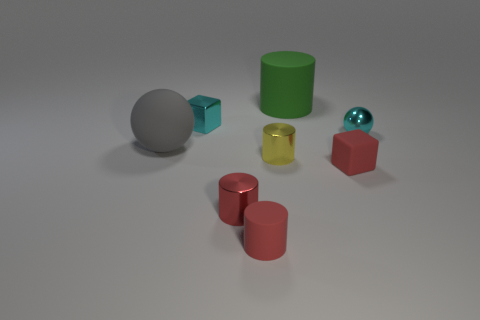Subtract all cyan cylinders. Subtract all green spheres. How many cylinders are left? 4 Add 1 large cyan matte cylinders. How many objects exist? 9 Subtract all blocks. How many objects are left? 6 Subtract all tiny red cylinders. Subtract all red cubes. How many objects are left? 5 Add 7 large rubber cylinders. How many large rubber cylinders are left? 8 Add 8 big green rubber cylinders. How many big green rubber cylinders exist? 9 Subtract 1 red blocks. How many objects are left? 7 